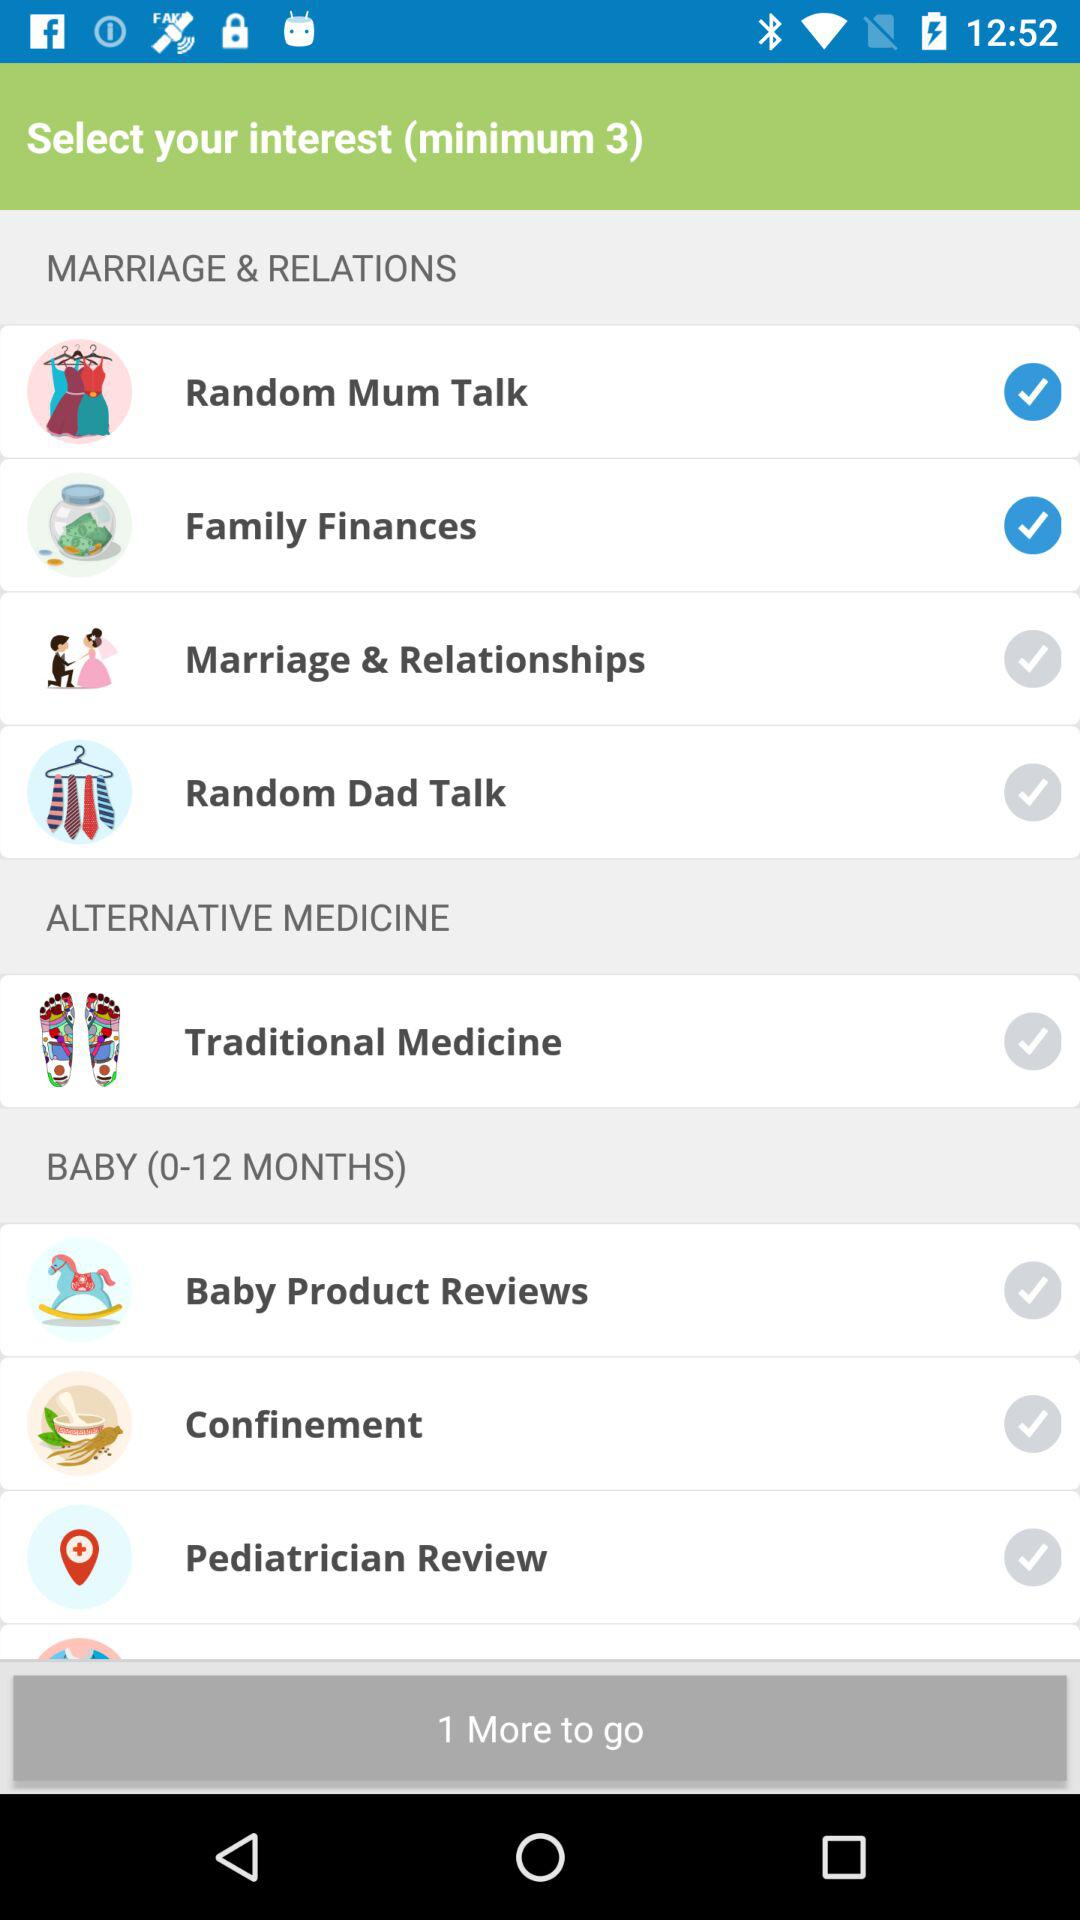What's the minimum number of interests the user has to select? The minimum number of interests the user has to select is 3. 